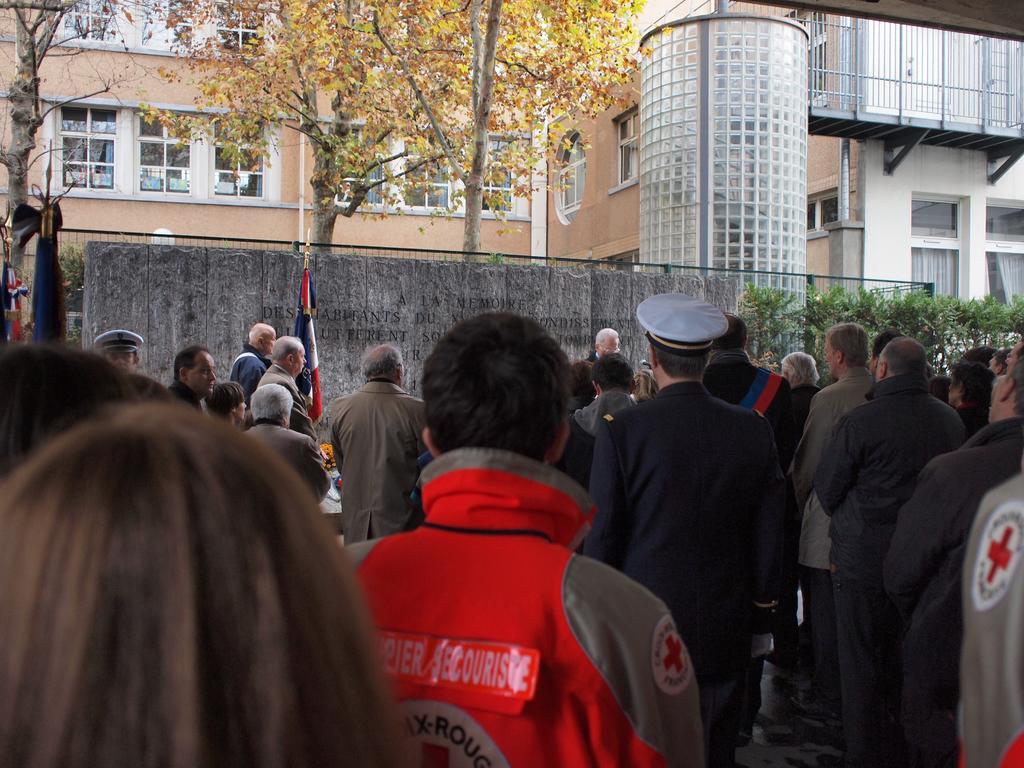Can you describe this image briefly? In the image there are many people standing. In front of them there are stone pillars with something written on it. Behind that there is a flag, fencing and also there are trees. In the background there are trees and buildings with walls, windows and glasses. 